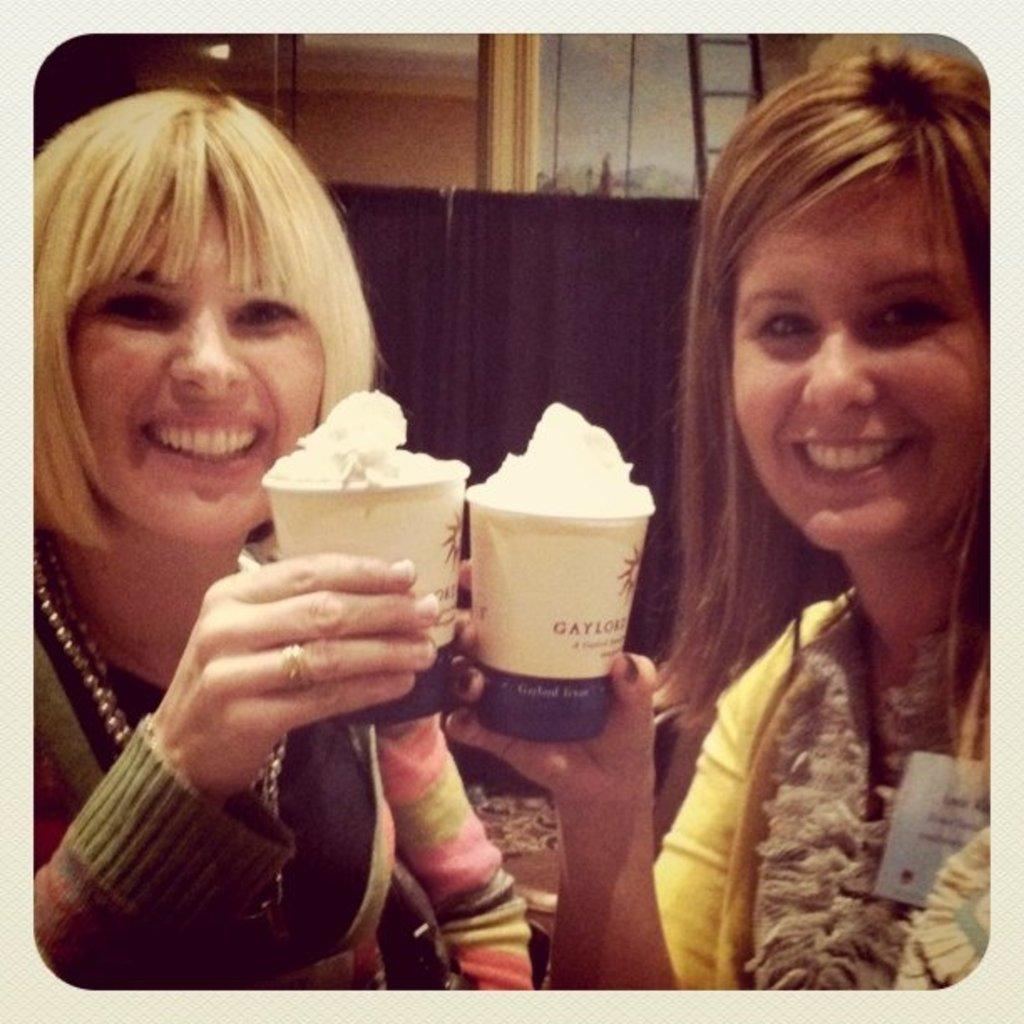Who is present in the image? There are women in the image. What are the women holding in the image? There are cups with a food item in the image. What can be seen in the background of the image? There is a curtain, a ladder, a wall, and other objects in the background of the image. What type of skirt is the wall wearing in the image? The wall is not wearing a skirt, as it is an inanimate object and does not have clothing. 